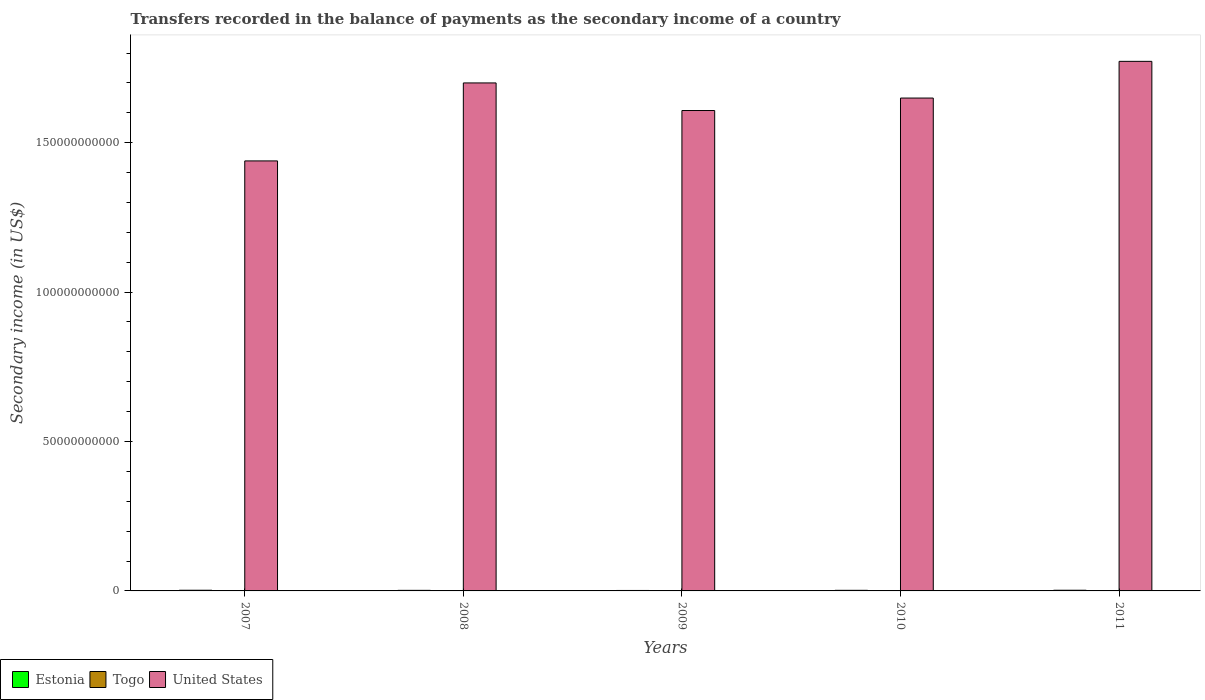How many groups of bars are there?
Keep it short and to the point. 5. Are the number of bars on each tick of the X-axis equal?
Make the answer very short. Yes. How many bars are there on the 5th tick from the left?
Make the answer very short. 3. How many bars are there on the 3rd tick from the right?
Keep it short and to the point. 3. What is the secondary income of in Estonia in 2009?
Your response must be concise. 1.52e+08. Across all years, what is the maximum secondary income of in Estonia?
Provide a succinct answer. 2.27e+08. Across all years, what is the minimum secondary income of in Estonia?
Keep it short and to the point. 1.52e+08. In which year was the secondary income of in United States maximum?
Give a very brief answer. 2011. In which year was the secondary income of in United States minimum?
Your response must be concise. 2007. What is the total secondary income of in United States in the graph?
Keep it short and to the point. 8.17e+11. What is the difference between the secondary income of in Estonia in 2007 and that in 2009?
Your response must be concise. 7.46e+07. What is the difference between the secondary income of in Estonia in 2008 and the secondary income of in United States in 2010?
Your answer should be compact. -1.65e+11. What is the average secondary income of in United States per year?
Your answer should be very brief. 1.63e+11. In the year 2010, what is the difference between the secondary income of in Togo and secondary income of in Estonia?
Provide a short and direct response. -1.47e+08. What is the ratio of the secondary income of in Estonia in 2009 to that in 2011?
Offer a terse response. 0.68. Is the difference between the secondary income of in Togo in 2008 and 2010 greater than the difference between the secondary income of in Estonia in 2008 and 2010?
Your answer should be very brief. Yes. What is the difference between the highest and the second highest secondary income of in United States?
Make the answer very short. 7.22e+09. What is the difference between the highest and the lowest secondary income of in United States?
Your answer should be compact. 3.33e+1. In how many years, is the secondary income of in United States greater than the average secondary income of in United States taken over all years?
Offer a very short reply. 3. What does the 3rd bar from the left in 2010 represents?
Offer a very short reply. United States. What does the 3rd bar from the right in 2007 represents?
Ensure brevity in your answer.  Estonia. Are all the bars in the graph horizontal?
Your answer should be very brief. No. How many years are there in the graph?
Give a very brief answer. 5. What is the difference between two consecutive major ticks on the Y-axis?
Give a very brief answer. 5.00e+1. Are the values on the major ticks of Y-axis written in scientific E-notation?
Make the answer very short. No. How many legend labels are there?
Keep it short and to the point. 3. What is the title of the graph?
Offer a very short reply. Transfers recorded in the balance of payments as the secondary income of a country. Does "Liechtenstein" appear as one of the legend labels in the graph?
Offer a very short reply. No. What is the label or title of the Y-axis?
Your answer should be very brief. Secondary income (in US$). What is the Secondary income (in US$) of Estonia in 2007?
Keep it short and to the point. 2.27e+08. What is the Secondary income (in US$) in Togo in 2007?
Your answer should be compact. 4.91e+07. What is the Secondary income (in US$) of United States in 2007?
Ensure brevity in your answer.  1.44e+11. What is the Secondary income (in US$) in Estonia in 2008?
Your response must be concise. 1.90e+08. What is the Secondary income (in US$) of Togo in 2008?
Offer a terse response. 5.82e+07. What is the Secondary income (in US$) of United States in 2008?
Make the answer very short. 1.70e+11. What is the Secondary income (in US$) of Estonia in 2009?
Offer a terse response. 1.52e+08. What is the Secondary income (in US$) in Togo in 2009?
Give a very brief answer. 7.19e+07. What is the Secondary income (in US$) of United States in 2009?
Your answer should be very brief. 1.61e+11. What is the Secondary income (in US$) in Estonia in 2010?
Ensure brevity in your answer.  2.03e+08. What is the Secondary income (in US$) of Togo in 2010?
Your answer should be compact. 5.58e+07. What is the Secondary income (in US$) of United States in 2010?
Offer a terse response. 1.65e+11. What is the Secondary income (in US$) in Estonia in 2011?
Offer a very short reply. 2.25e+08. What is the Secondary income (in US$) of Togo in 2011?
Offer a very short reply. 7.87e+07. What is the Secondary income (in US$) in United States in 2011?
Your answer should be very brief. 1.77e+11. Across all years, what is the maximum Secondary income (in US$) of Estonia?
Offer a terse response. 2.27e+08. Across all years, what is the maximum Secondary income (in US$) of Togo?
Your answer should be compact. 7.87e+07. Across all years, what is the maximum Secondary income (in US$) in United States?
Make the answer very short. 1.77e+11. Across all years, what is the minimum Secondary income (in US$) in Estonia?
Offer a terse response. 1.52e+08. Across all years, what is the minimum Secondary income (in US$) in Togo?
Your answer should be very brief. 4.91e+07. Across all years, what is the minimum Secondary income (in US$) in United States?
Your answer should be very brief. 1.44e+11. What is the total Secondary income (in US$) of Estonia in the graph?
Your answer should be compact. 9.97e+08. What is the total Secondary income (in US$) of Togo in the graph?
Make the answer very short. 3.14e+08. What is the total Secondary income (in US$) in United States in the graph?
Offer a very short reply. 8.17e+11. What is the difference between the Secondary income (in US$) in Estonia in 2007 and that in 2008?
Make the answer very short. 3.72e+07. What is the difference between the Secondary income (in US$) of Togo in 2007 and that in 2008?
Provide a short and direct response. -9.14e+06. What is the difference between the Secondary income (in US$) in United States in 2007 and that in 2008?
Give a very brief answer. -2.61e+1. What is the difference between the Secondary income (in US$) of Estonia in 2007 and that in 2009?
Provide a succinct answer. 7.46e+07. What is the difference between the Secondary income (in US$) of Togo in 2007 and that in 2009?
Ensure brevity in your answer.  -2.27e+07. What is the difference between the Secondary income (in US$) in United States in 2007 and that in 2009?
Offer a terse response. -1.69e+1. What is the difference between the Secondary income (in US$) in Estonia in 2007 and that in 2010?
Offer a terse response. 2.43e+07. What is the difference between the Secondary income (in US$) in Togo in 2007 and that in 2010?
Keep it short and to the point. -6.70e+06. What is the difference between the Secondary income (in US$) of United States in 2007 and that in 2010?
Offer a terse response. -2.10e+1. What is the difference between the Secondary income (in US$) in Estonia in 2007 and that in 2011?
Make the answer very short. 1.67e+06. What is the difference between the Secondary income (in US$) in Togo in 2007 and that in 2011?
Offer a very short reply. -2.96e+07. What is the difference between the Secondary income (in US$) in United States in 2007 and that in 2011?
Provide a short and direct response. -3.33e+1. What is the difference between the Secondary income (in US$) in Estonia in 2008 and that in 2009?
Give a very brief answer. 3.75e+07. What is the difference between the Secondary income (in US$) in Togo in 2008 and that in 2009?
Provide a short and direct response. -1.36e+07. What is the difference between the Secondary income (in US$) of United States in 2008 and that in 2009?
Keep it short and to the point. 9.24e+09. What is the difference between the Secondary income (in US$) in Estonia in 2008 and that in 2010?
Give a very brief answer. -1.28e+07. What is the difference between the Secondary income (in US$) of Togo in 2008 and that in 2010?
Your response must be concise. 2.44e+06. What is the difference between the Secondary income (in US$) in United States in 2008 and that in 2010?
Keep it short and to the point. 5.06e+09. What is the difference between the Secondary income (in US$) in Estonia in 2008 and that in 2011?
Give a very brief answer. -3.55e+07. What is the difference between the Secondary income (in US$) in Togo in 2008 and that in 2011?
Provide a succinct answer. -2.05e+07. What is the difference between the Secondary income (in US$) of United States in 2008 and that in 2011?
Ensure brevity in your answer.  -7.22e+09. What is the difference between the Secondary income (in US$) in Estonia in 2009 and that in 2010?
Offer a very short reply. -5.03e+07. What is the difference between the Secondary income (in US$) of Togo in 2009 and that in 2010?
Provide a short and direct response. 1.60e+07. What is the difference between the Secondary income (in US$) in United States in 2009 and that in 2010?
Ensure brevity in your answer.  -4.17e+09. What is the difference between the Secondary income (in US$) in Estonia in 2009 and that in 2011?
Your response must be concise. -7.29e+07. What is the difference between the Secondary income (in US$) in Togo in 2009 and that in 2011?
Make the answer very short. -6.86e+06. What is the difference between the Secondary income (in US$) in United States in 2009 and that in 2011?
Your answer should be very brief. -1.65e+1. What is the difference between the Secondary income (in US$) in Estonia in 2010 and that in 2011?
Your answer should be very brief. -2.26e+07. What is the difference between the Secondary income (in US$) in Togo in 2010 and that in 2011?
Your answer should be compact. -2.29e+07. What is the difference between the Secondary income (in US$) of United States in 2010 and that in 2011?
Give a very brief answer. -1.23e+1. What is the difference between the Secondary income (in US$) of Estonia in 2007 and the Secondary income (in US$) of Togo in 2008?
Your answer should be very brief. 1.69e+08. What is the difference between the Secondary income (in US$) of Estonia in 2007 and the Secondary income (in US$) of United States in 2008?
Offer a very short reply. -1.70e+11. What is the difference between the Secondary income (in US$) of Togo in 2007 and the Secondary income (in US$) of United States in 2008?
Your answer should be compact. -1.70e+11. What is the difference between the Secondary income (in US$) in Estonia in 2007 and the Secondary income (in US$) in Togo in 2009?
Provide a short and direct response. 1.55e+08. What is the difference between the Secondary income (in US$) of Estonia in 2007 and the Secondary income (in US$) of United States in 2009?
Keep it short and to the point. -1.61e+11. What is the difference between the Secondary income (in US$) in Togo in 2007 and the Secondary income (in US$) in United States in 2009?
Provide a short and direct response. -1.61e+11. What is the difference between the Secondary income (in US$) of Estonia in 2007 and the Secondary income (in US$) of Togo in 2010?
Provide a short and direct response. 1.71e+08. What is the difference between the Secondary income (in US$) of Estonia in 2007 and the Secondary income (in US$) of United States in 2010?
Offer a terse response. -1.65e+11. What is the difference between the Secondary income (in US$) of Togo in 2007 and the Secondary income (in US$) of United States in 2010?
Ensure brevity in your answer.  -1.65e+11. What is the difference between the Secondary income (in US$) in Estonia in 2007 and the Secondary income (in US$) in Togo in 2011?
Keep it short and to the point. 1.48e+08. What is the difference between the Secondary income (in US$) of Estonia in 2007 and the Secondary income (in US$) of United States in 2011?
Provide a short and direct response. -1.77e+11. What is the difference between the Secondary income (in US$) of Togo in 2007 and the Secondary income (in US$) of United States in 2011?
Your response must be concise. -1.77e+11. What is the difference between the Secondary income (in US$) in Estonia in 2008 and the Secondary income (in US$) in Togo in 2009?
Your response must be concise. 1.18e+08. What is the difference between the Secondary income (in US$) of Estonia in 2008 and the Secondary income (in US$) of United States in 2009?
Provide a succinct answer. -1.61e+11. What is the difference between the Secondary income (in US$) of Togo in 2008 and the Secondary income (in US$) of United States in 2009?
Your response must be concise. -1.61e+11. What is the difference between the Secondary income (in US$) of Estonia in 2008 and the Secondary income (in US$) of Togo in 2010?
Your response must be concise. 1.34e+08. What is the difference between the Secondary income (in US$) in Estonia in 2008 and the Secondary income (in US$) in United States in 2010?
Your answer should be very brief. -1.65e+11. What is the difference between the Secondary income (in US$) of Togo in 2008 and the Secondary income (in US$) of United States in 2010?
Your answer should be very brief. -1.65e+11. What is the difference between the Secondary income (in US$) of Estonia in 2008 and the Secondary income (in US$) of Togo in 2011?
Your answer should be compact. 1.11e+08. What is the difference between the Secondary income (in US$) of Estonia in 2008 and the Secondary income (in US$) of United States in 2011?
Provide a short and direct response. -1.77e+11. What is the difference between the Secondary income (in US$) in Togo in 2008 and the Secondary income (in US$) in United States in 2011?
Provide a succinct answer. -1.77e+11. What is the difference between the Secondary income (in US$) in Estonia in 2009 and the Secondary income (in US$) in Togo in 2010?
Your answer should be compact. 9.64e+07. What is the difference between the Secondary income (in US$) of Estonia in 2009 and the Secondary income (in US$) of United States in 2010?
Your response must be concise. -1.65e+11. What is the difference between the Secondary income (in US$) in Togo in 2009 and the Secondary income (in US$) in United States in 2010?
Keep it short and to the point. -1.65e+11. What is the difference between the Secondary income (in US$) in Estonia in 2009 and the Secondary income (in US$) in Togo in 2011?
Make the answer very short. 7.35e+07. What is the difference between the Secondary income (in US$) in Estonia in 2009 and the Secondary income (in US$) in United States in 2011?
Your response must be concise. -1.77e+11. What is the difference between the Secondary income (in US$) of Togo in 2009 and the Secondary income (in US$) of United States in 2011?
Ensure brevity in your answer.  -1.77e+11. What is the difference between the Secondary income (in US$) of Estonia in 2010 and the Secondary income (in US$) of Togo in 2011?
Your response must be concise. 1.24e+08. What is the difference between the Secondary income (in US$) of Estonia in 2010 and the Secondary income (in US$) of United States in 2011?
Provide a short and direct response. -1.77e+11. What is the difference between the Secondary income (in US$) in Togo in 2010 and the Secondary income (in US$) in United States in 2011?
Keep it short and to the point. -1.77e+11. What is the average Secondary income (in US$) of Estonia per year?
Offer a very short reply. 1.99e+08. What is the average Secondary income (in US$) in Togo per year?
Provide a succinct answer. 6.27e+07. What is the average Secondary income (in US$) in United States per year?
Your answer should be very brief. 1.63e+11. In the year 2007, what is the difference between the Secondary income (in US$) of Estonia and Secondary income (in US$) of Togo?
Offer a very short reply. 1.78e+08. In the year 2007, what is the difference between the Secondary income (in US$) in Estonia and Secondary income (in US$) in United States?
Provide a succinct answer. -1.44e+11. In the year 2007, what is the difference between the Secondary income (in US$) in Togo and Secondary income (in US$) in United States?
Your response must be concise. -1.44e+11. In the year 2008, what is the difference between the Secondary income (in US$) in Estonia and Secondary income (in US$) in Togo?
Provide a succinct answer. 1.31e+08. In the year 2008, what is the difference between the Secondary income (in US$) of Estonia and Secondary income (in US$) of United States?
Keep it short and to the point. -1.70e+11. In the year 2008, what is the difference between the Secondary income (in US$) of Togo and Secondary income (in US$) of United States?
Your response must be concise. -1.70e+11. In the year 2009, what is the difference between the Secondary income (in US$) of Estonia and Secondary income (in US$) of Togo?
Provide a short and direct response. 8.04e+07. In the year 2009, what is the difference between the Secondary income (in US$) in Estonia and Secondary income (in US$) in United States?
Your answer should be very brief. -1.61e+11. In the year 2009, what is the difference between the Secondary income (in US$) in Togo and Secondary income (in US$) in United States?
Your answer should be compact. -1.61e+11. In the year 2010, what is the difference between the Secondary income (in US$) in Estonia and Secondary income (in US$) in Togo?
Your response must be concise. 1.47e+08. In the year 2010, what is the difference between the Secondary income (in US$) of Estonia and Secondary income (in US$) of United States?
Provide a short and direct response. -1.65e+11. In the year 2010, what is the difference between the Secondary income (in US$) of Togo and Secondary income (in US$) of United States?
Provide a succinct answer. -1.65e+11. In the year 2011, what is the difference between the Secondary income (in US$) of Estonia and Secondary income (in US$) of Togo?
Give a very brief answer. 1.46e+08. In the year 2011, what is the difference between the Secondary income (in US$) in Estonia and Secondary income (in US$) in United States?
Keep it short and to the point. -1.77e+11. In the year 2011, what is the difference between the Secondary income (in US$) of Togo and Secondary income (in US$) of United States?
Offer a very short reply. -1.77e+11. What is the ratio of the Secondary income (in US$) in Estonia in 2007 to that in 2008?
Make the answer very short. 1.2. What is the ratio of the Secondary income (in US$) in Togo in 2007 to that in 2008?
Your answer should be very brief. 0.84. What is the ratio of the Secondary income (in US$) in United States in 2007 to that in 2008?
Provide a short and direct response. 0.85. What is the ratio of the Secondary income (in US$) of Estonia in 2007 to that in 2009?
Provide a short and direct response. 1.49. What is the ratio of the Secondary income (in US$) of Togo in 2007 to that in 2009?
Give a very brief answer. 0.68. What is the ratio of the Secondary income (in US$) in United States in 2007 to that in 2009?
Your response must be concise. 0.9. What is the ratio of the Secondary income (in US$) in Estonia in 2007 to that in 2010?
Offer a terse response. 1.12. What is the ratio of the Secondary income (in US$) of Togo in 2007 to that in 2010?
Offer a terse response. 0.88. What is the ratio of the Secondary income (in US$) in United States in 2007 to that in 2010?
Your answer should be compact. 0.87. What is the ratio of the Secondary income (in US$) in Estonia in 2007 to that in 2011?
Give a very brief answer. 1.01. What is the ratio of the Secondary income (in US$) of Togo in 2007 to that in 2011?
Keep it short and to the point. 0.62. What is the ratio of the Secondary income (in US$) in United States in 2007 to that in 2011?
Your answer should be very brief. 0.81. What is the ratio of the Secondary income (in US$) of Estonia in 2008 to that in 2009?
Provide a succinct answer. 1.25. What is the ratio of the Secondary income (in US$) of Togo in 2008 to that in 2009?
Ensure brevity in your answer.  0.81. What is the ratio of the Secondary income (in US$) of United States in 2008 to that in 2009?
Make the answer very short. 1.06. What is the ratio of the Secondary income (in US$) in Estonia in 2008 to that in 2010?
Offer a very short reply. 0.94. What is the ratio of the Secondary income (in US$) of Togo in 2008 to that in 2010?
Provide a short and direct response. 1.04. What is the ratio of the Secondary income (in US$) in United States in 2008 to that in 2010?
Your answer should be very brief. 1.03. What is the ratio of the Secondary income (in US$) in Estonia in 2008 to that in 2011?
Your response must be concise. 0.84. What is the ratio of the Secondary income (in US$) of Togo in 2008 to that in 2011?
Keep it short and to the point. 0.74. What is the ratio of the Secondary income (in US$) of United States in 2008 to that in 2011?
Your response must be concise. 0.96. What is the ratio of the Secondary income (in US$) of Estonia in 2009 to that in 2010?
Your answer should be very brief. 0.75. What is the ratio of the Secondary income (in US$) of Togo in 2009 to that in 2010?
Provide a short and direct response. 1.29. What is the ratio of the Secondary income (in US$) in United States in 2009 to that in 2010?
Provide a succinct answer. 0.97. What is the ratio of the Secondary income (in US$) in Estonia in 2009 to that in 2011?
Ensure brevity in your answer.  0.68. What is the ratio of the Secondary income (in US$) in Togo in 2009 to that in 2011?
Ensure brevity in your answer.  0.91. What is the ratio of the Secondary income (in US$) in United States in 2009 to that in 2011?
Ensure brevity in your answer.  0.91. What is the ratio of the Secondary income (in US$) of Estonia in 2010 to that in 2011?
Your answer should be compact. 0.9. What is the ratio of the Secondary income (in US$) of Togo in 2010 to that in 2011?
Your answer should be compact. 0.71. What is the ratio of the Secondary income (in US$) of United States in 2010 to that in 2011?
Your answer should be compact. 0.93. What is the difference between the highest and the second highest Secondary income (in US$) in Estonia?
Keep it short and to the point. 1.67e+06. What is the difference between the highest and the second highest Secondary income (in US$) in Togo?
Offer a terse response. 6.86e+06. What is the difference between the highest and the second highest Secondary income (in US$) in United States?
Make the answer very short. 7.22e+09. What is the difference between the highest and the lowest Secondary income (in US$) in Estonia?
Provide a succinct answer. 7.46e+07. What is the difference between the highest and the lowest Secondary income (in US$) in Togo?
Give a very brief answer. 2.96e+07. What is the difference between the highest and the lowest Secondary income (in US$) of United States?
Your answer should be compact. 3.33e+1. 